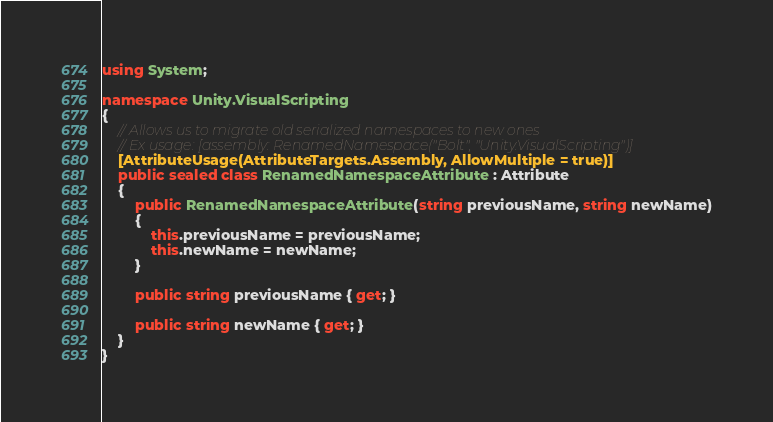Convert code to text. <code><loc_0><loc_0><loc_500><loc_500><_C#_>using System;

namespace Unity.VisualScripting
{
    // Allows us to migrate old serialized namespaces to new ones
    // Ex usage: [assembly: RenamedNamespace("Bolt", "Unity.VisualScripting")]
    [AttributeUsage(AttributeTargets.Assembly, AllowMultiple = true)]
    public sealed class RenamedNamespaceAttribute : Attribute
    {
        public RenamedNamespaceAttribute(string previousName, string newName)
        {
            this.previousName = previousName;
            this.newName = newName;
        }

        public string previousName { get; }

        public string newName { get; }
    }
}
</code> 